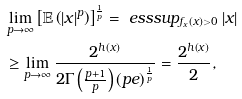Convert formula to latex. <formula><loc_0><loc_0><loc_500><loc_500>& \lim _ { p \to \infty } \left [ \mathbb { E } \left ( \left | x \right | ^ { p } \right ) \right ] ^ { \frac { 1 } { p } } = \ e s s s u p _ { f _ { x } \left ( x \right ) > 0 } \left | x \right | \\ & \geq \lim _ { p \to \infty } \frac { 2 ^ { h \left ( x \right ) } } { 2 \Gamma \left ( \frac { p + 1 } { p } \right ) \left ( p e \right ) ^ { \frac { 1 } { p } } } = \frac { 2 ^ { h \left ( x \right ) } } { 2 } ,</formula> 